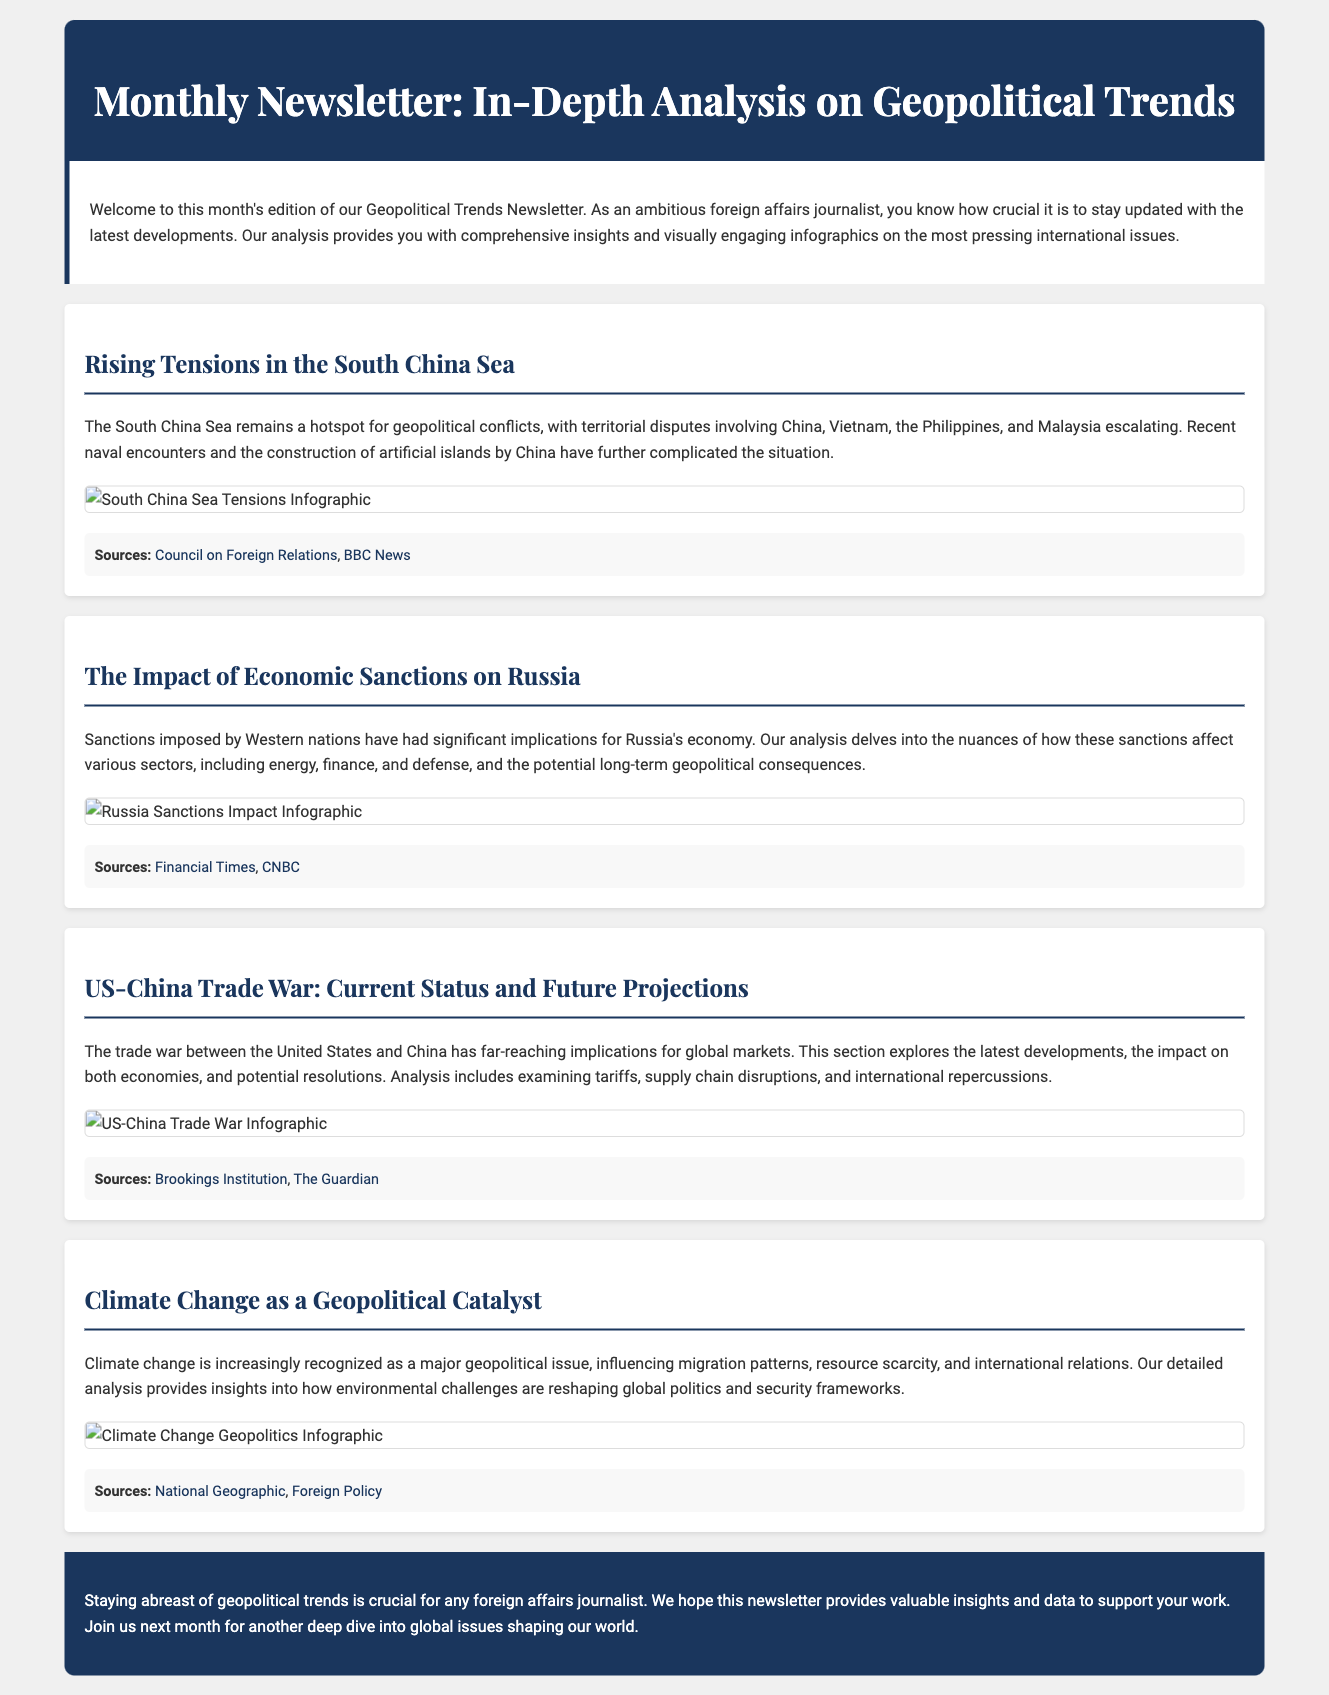What is the title of the newsletter? The title of the newsletter is prominently displayed in the header section of the document.
Answer: Monthly Newsletter: In-Depth Analysis on Geopolitical Trends Who is the target audience for this newsletter? The introductory section mentions that the newsletter is aimed at a specific group of readers.
Answer: foreign affairs journalists What issue is highlighted in the section about the South China Sea? The section discusses a particular geopolitical conflict involving multiple countries.
Answer: territorial disputes What significant economic implications are analyzed regarding sanctions on Russia? The document outlines the impact of sanctions on various sectors of Russia's economy.
Answer: energy, finance, and defense Which two organizations are cited as sources for the US-China Trade War section? The sources section includes links to publications that provide insights into the topic.
Answer: Brookings Institution, The Guardian How does the document characterize climate change? The section on climate change presents it as influencing multiple international dynamics.
Answer: a major geopolitical issue What visual element is included to supplement the geopolitical analyses? Each section enhances understanding of the content through a specific type of visual aid.
Answer: infographics What is the background color of the conclusion section? The design of the document incorporates specific colors for different sections, including this one.
Answer: #1a365d 